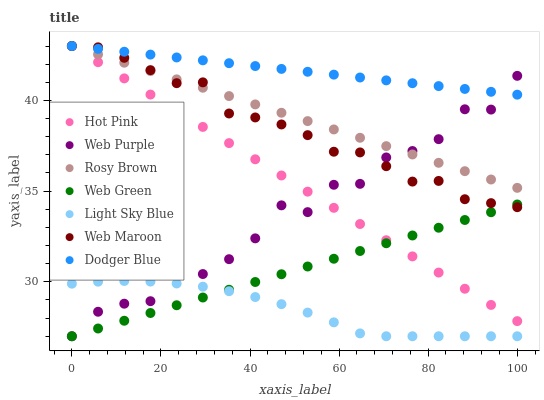Does Light Sky Blue have the minimum area under the curve?
Answer yes or no. Yes. Does Dodger Blue have the maximum area under the curve?
Answer yes or no. Yes. Does Hot Pink have the minimum area under the curve?
Answer yes or no. No. Does Hot Pink have the maximum area under the curve?
Answer yes or no. No. Is Web Green the smoothest?
Answer yes or no. Yes. Is Web Purple the roughest?
Answer yes or no. Yes. Is Hot Pink the smoothest?
Answer yes or no. No. Is Hot Pink the roughest?
Answer yes or no. No. Does Web Green have the lowest value?
Answer yes or no. Yes. Does Hot Pink have the lowest value?
Answer yes or no. No. Does Dodger Blue have the highest value?
Answer yes or no. Yes. Does Web Green have the highest value?
Answer yes or no. No. Is Light Sky Blue less than Web Maroon?
Answer yes or no. Yes. Is Dodger Blue greater than Web Green?
Answer yes or no. Yes. Does Web Purple intersect Rosy Brown?
Answer yes or no. Yes. Is Web Purple less than Rosy Brown?
Answer yes or no. No. Is Web Purple greater than Rosy Brown?
Answer yes or no. No. Does Light Sky Blue intersect Web Maroon?
Answer yes or no. No. 